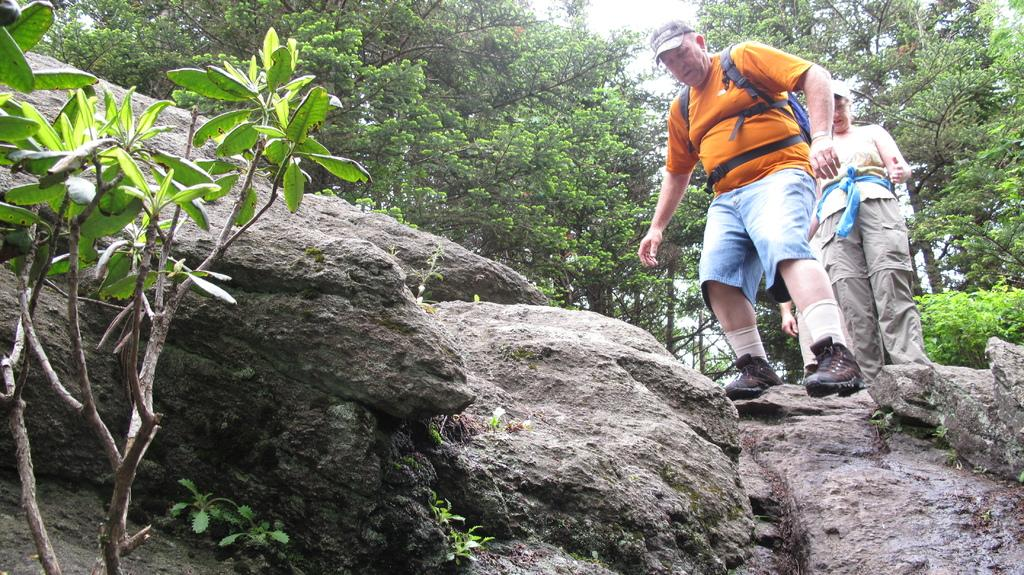How many people are in the image? There are people in the image, but the exact number is not specified. What are the people doing in the image? The people are standing in the image. What are the people wearing on their heads? The people are wearing caps in the image. What is the terrain like where the people are standing? The people are standing on rocks in the image. What can be seen in the background of the image? There are trees visible in the background of the image. What type of cough medicine is the person holding in the image? There is no cough medicine or any indication of a cough in the image. What is the van used for in the image? There is no van present in the image. 